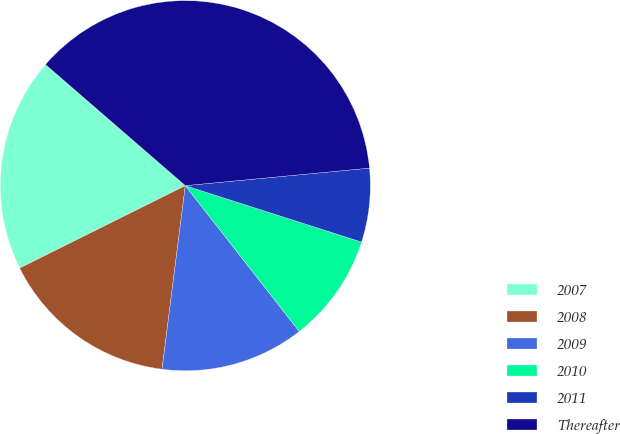<chart> <loc_0><loc_0><loc_500><loc_500><pie_chart><fcel>2007<fcel>2008<fcel>2009<fcel>2010<fcel>2011<fcel>Thereafter<nl><fcel>18.71%<fcel>15.64%<fcel>12.57%<fcel>9.51%<fcel>6.44%<fcel>37.13%<nl></chart> 